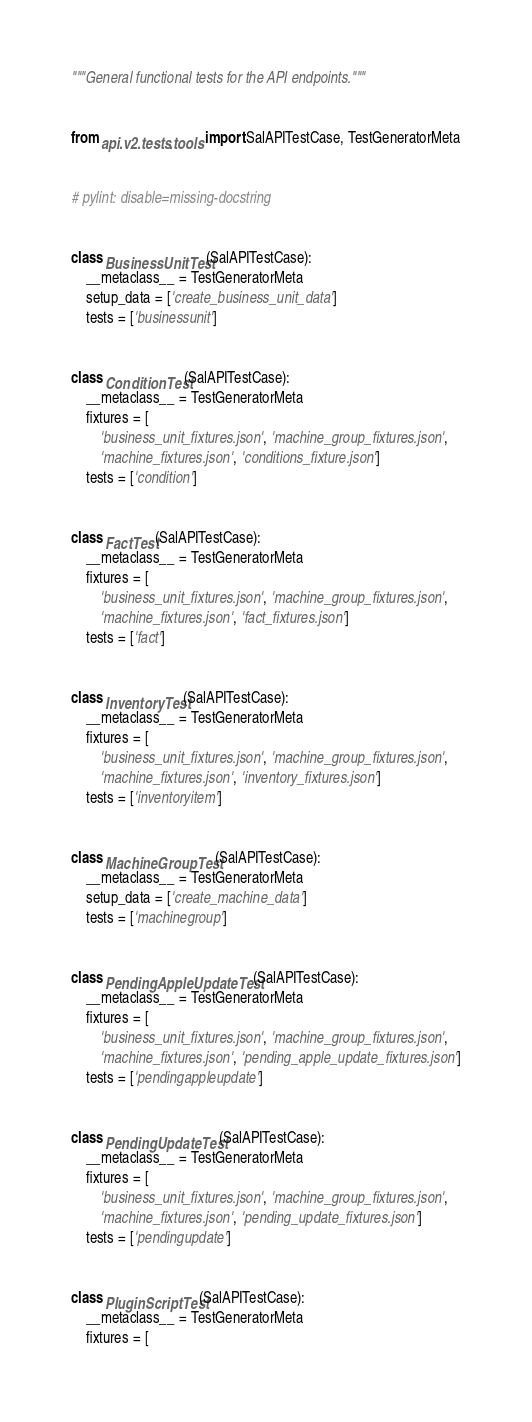<code> <loc_0><loc_0><loc_500><loc_500><_Python_>"""General functional tests for the API endpoints."""


from api.v2.tests.tools import SalAPITestCase, TestGeneratorMeta


# pylint: disable=missing-docstring


class BusinessUnitTest(SalAPITestCase):
    __metaclass__ = TestGeneratorMeta
    setup_data = ['create_business_unit_data']
    tests = ['businessunit']


class ConditionTest(SalAPITestCase):
    __metaclass__ = TestGeneratorMeta
    fixtures = [
        'business_unit_fixtures.json', 'machine_group_fixtures.json',
        'machine_fixtures.json', 'conditions_fixture.json']
    tests = ['condition']


class FactTest(SalAPITestCase):
    __metaclass__ = TestGeneratorMeta
    fixtures = [
        'business_unit_fixtures.json', 'machine_group_fixtures.json',
        'machine_fixtures.json', 'fact_fixtures.json']
    tests = ['fact']


class InventoryTest(SalAPITestCase):
    __metaclass__ = TestGeneratorMeta
    fixtures = [
        'business_unit_fixtures.json', 'machine_group_fixtures.json',
        'machine_fixtures.json', 'inventory_fixtures.json']
    tests = ['inventoryitem']


class MachineGroupTest(SalAPITestCase):
    __metaclass__ = TestGeneratorMeta
    setup_data = ['create_machine_data']
    tests = ['machinegroup']


class PendingAppleUpdateTest(SalAPITestCase):
    __metaclass__ = TestGeneratorMeta
    fixtures = [
        'business_unit_fixtures.json', 'machine_group_fixtures.json',
        'machine_fixtures.json', 'pending_apple_update_fixtures.json']
    tests = ['pendingappleupdate']


class PendingUpdateTest(SalAPITestCase):
    __metaclass__ = TestGeneratorMeta
    fixtures = [
        'business_unit_fixtures.json', 'machine_group_fixtures.json',
        'machine_fixtures.json', 'pending_update_fixtures.json']
    tests = ['pendingupdate']


class PluginScriptTest(SalAPITestCase):
    __metaclass__ = TestGeneratorMeta
    fixtures = [</code> 